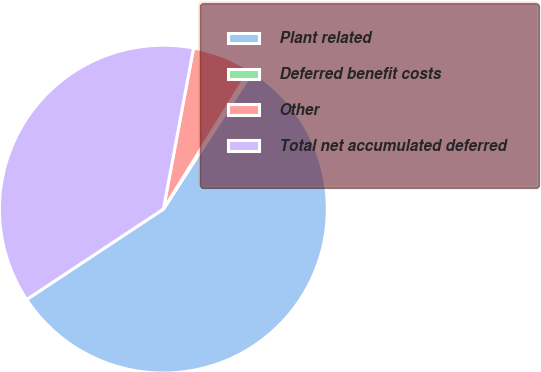Convert chart. <chart><loc_0><loc_0><loc_500><loc_500><pie_chart><fcel>Plant related<fcel>Deferred benefit costs<fcel>Other<fcel>Total net accumulated deferred<nl><fcel>56.57%<fcel>0.28%<fcel>5.91%<fcel>37.25%<nl></chart> 